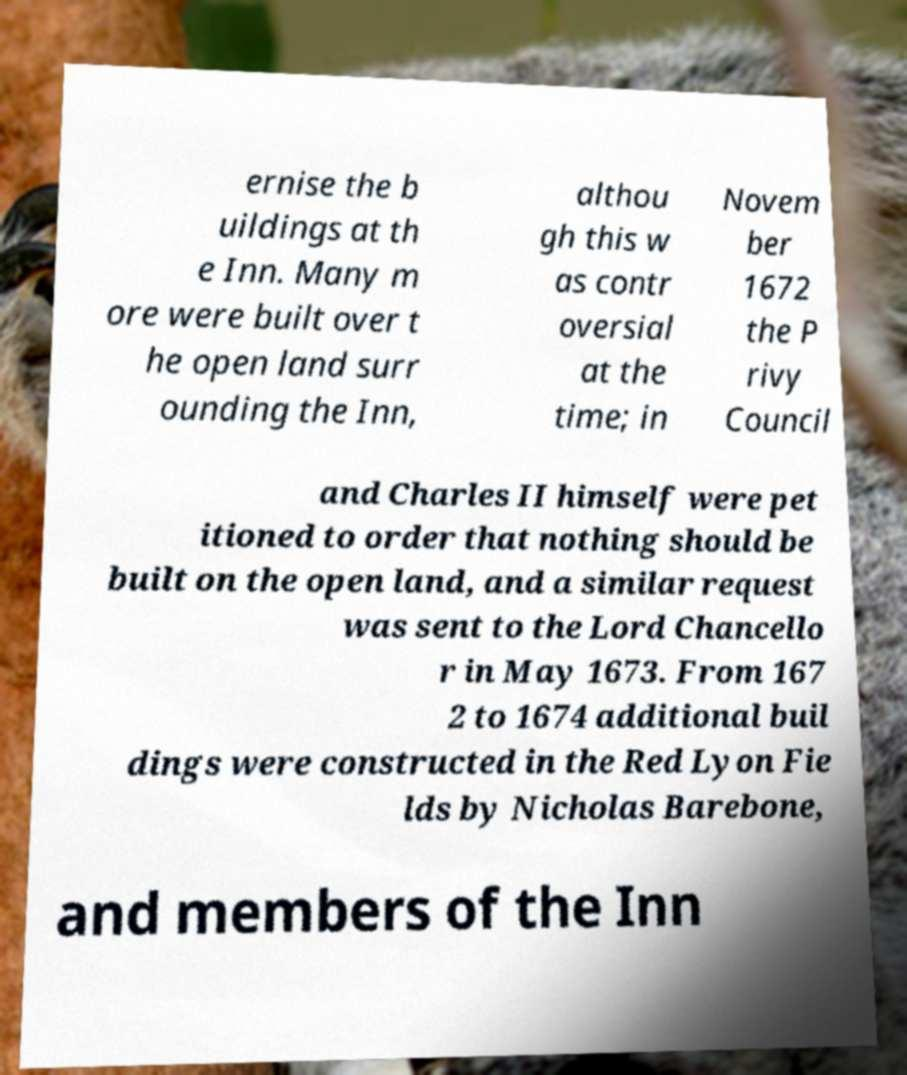Can you accurately transcribe the text from the provided image for me? ernise the b uildings at th e Inn. Many m ore were built over t he open land surr ounding the Inn, althou gh this w as contr oversial at the time; in Novem ber 1672 the P rivy Council and Charles II himself were pet itioned to order that nothing should be built on the open land, and a similar request was sent to the Lord Chancello r in May 1673. From 167 2 to 1674 additional buil dings were constructed in the Red Lyon Fie lds by Nicholas Barebone, and members of the Inn 